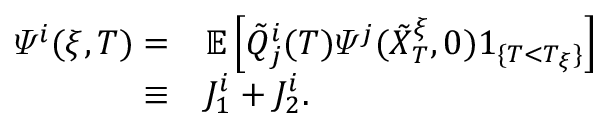<formula> <loc_0><loc_0><loc_500><loc_500>\begin{array} { r l } { \varPsi ^ { i } ( \xi , T ) = } & \mathbb { E } \left [ \tilde { Q } _ { j } ^ { i } ( T ) \varPsi ^ { j } ( \tilde { X } _ { T } ^ { \xi } , 0 ) 1 _ { \{ T < T _ { \xi } \} } \right ] } \\ { \equiv } & J _ { 1 } ^ { i } + J _ { 2 } ^ { i } . } \end{array}</formula> 